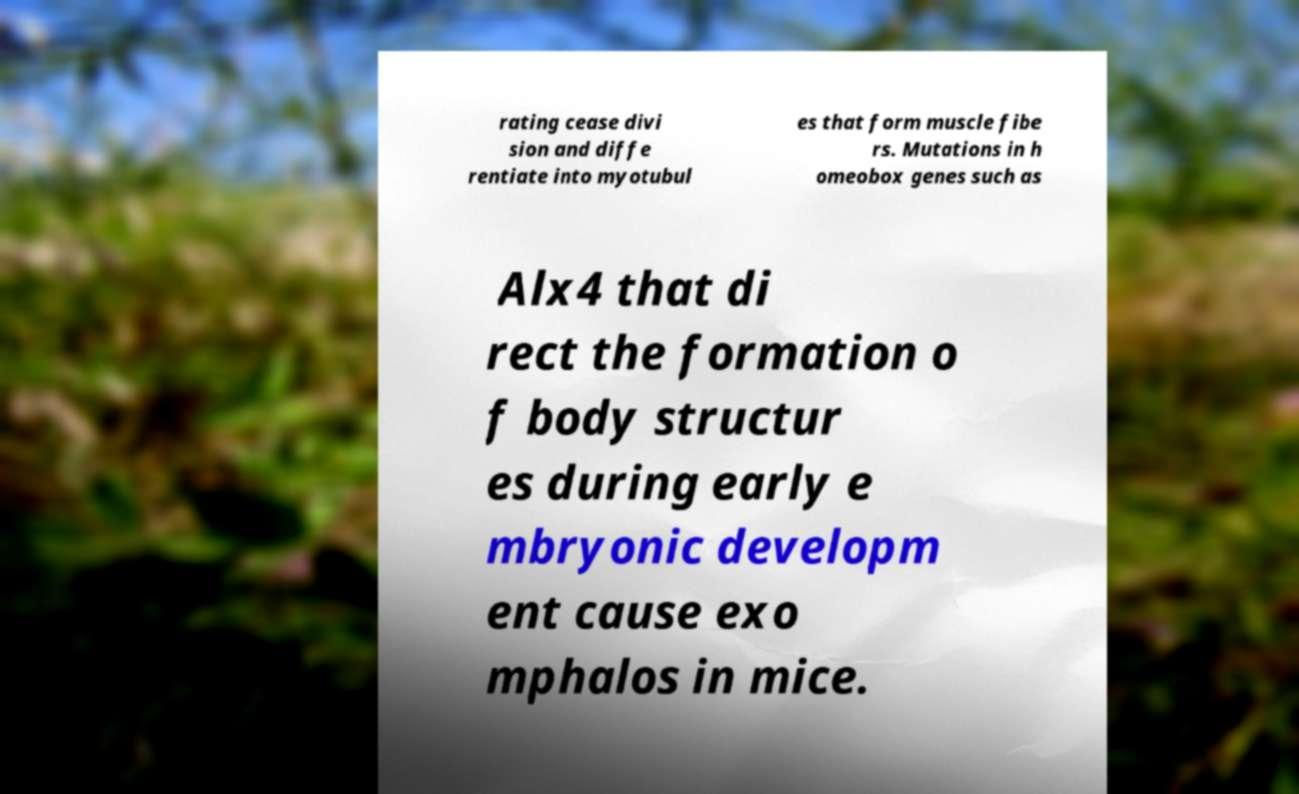I need the written content from this picture converted into text. Can you do that? rating cease divi sion and diffe rentiate into myotubul es that form muscle fibe rs. Mutations in h omeobox genes such as Alx4 that di rect the formation o f body structur es during early e mbryonic developm ent cause exo mphalos in mice. 